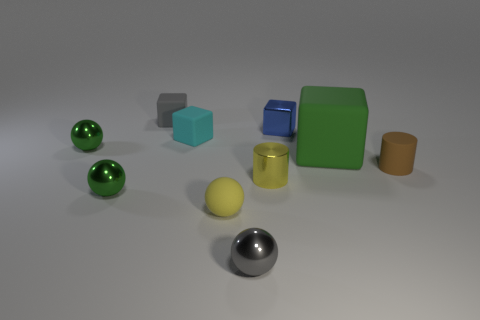Subtract 1 blocks. How many blocks are left? 3 Subtract all spheres. How many objects are left? 6 Add 1 tiny gray objects. How many tiny gray objects exist? 3 Subtract 0 purple balls. How many objects are left? 10 Subtract all small yellow rubber balls. Subtract all large green cubes. How many objects are left? 8 Add 5 gray matte objects. How many gray matte objects are left? 6 